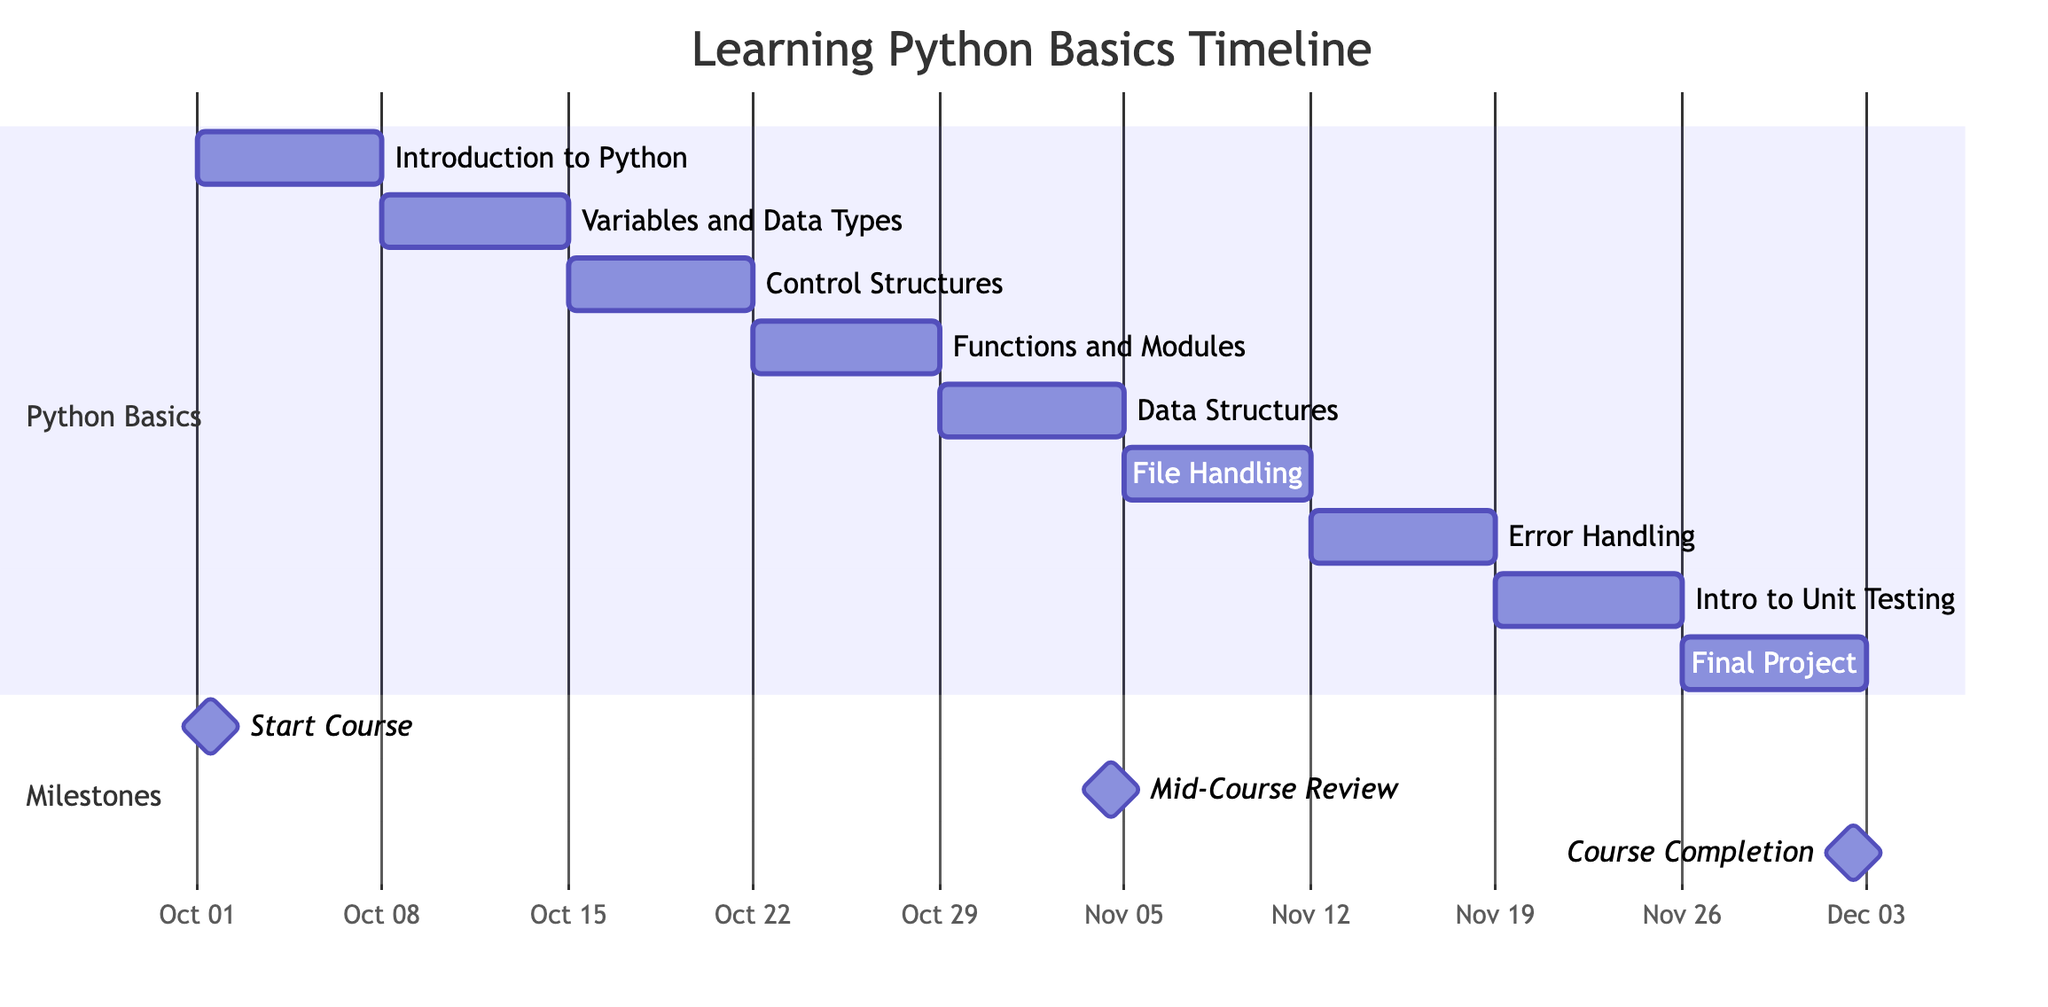What's the duration of the "Error Handling and Exceptions" task? The duration of each task in the Gantt chart is specified to be 7 days. Hence, for "Error Handling and Exceptions," the same duration applies.
Answer: 7 days When does the "Final Project" start? The Gantt chart specifies the "Final Project" task starting on 2023-11-26. This is directly indicated at the beginning of that task's entry.
Answer: 2023-11-26 How many tasks are listed in the Gantt chart? Counting each entry in the "Python Basics" section, there are a total of 9 tasks listed, as seen within the provided detail.
Answer: 9 What is the milestone for the course completion? The milestone labeled "Course Completion" represents the end of the course timeline, scheduled for 2023-12-02, as indicated in the milestones section.
Answer: Course Completion Which task directly follows "Functions and Modules"? The task that follows "Functions and Modules" is "Data Structures," according to the sequential arrangement of tasks in the Gantt chart.
Answer: Data Structures What is the start date of the "Introduction to Unit Testing"? The Gantt chart indicates that the "Introduction to Unit Testing" task begins on 2023-11-19, clearly laid out in its respective entry.
Answer: 2023-11-19 Which milestone occurs before the mid-course review? The milestone "Start Course" occurs before the "Mid-Course Review," as it is listed first chronologically among the milestones.
Answer: Start Course How many days does the entire course timeline span? The course starts on 2023-10-01 and ends on 2023-12-02. Calculating the total duration from the start to end results in 63 days.
Answer: 63 days Which section contains the task "File Handling"? The "File Handling" task is found in the "Python Basics" section, distinguishing it from the separate milestones section shown in the Gantt chart.
Answer: Python Basics 